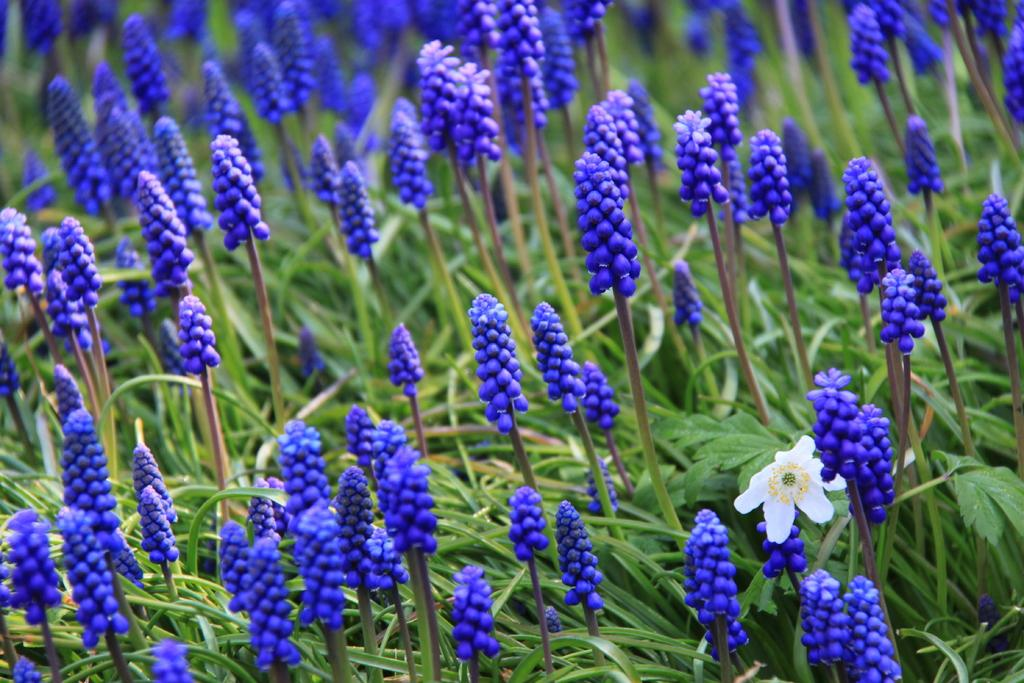What type of vegetation can be seen in the image? There are trees in the image. What is the color of the trees in the image? The trees are green in color. What other type of plant life is visible in the image? There are flowers in the image. What colors are the flowers in the image? The flowers are violet, white, and yellow in color. How many dogs are sitting on the lettuce in the image? There are no dogs or lettuce present in the image. What type of secretary can be seen working in the image? There is no secretary present in the image. 